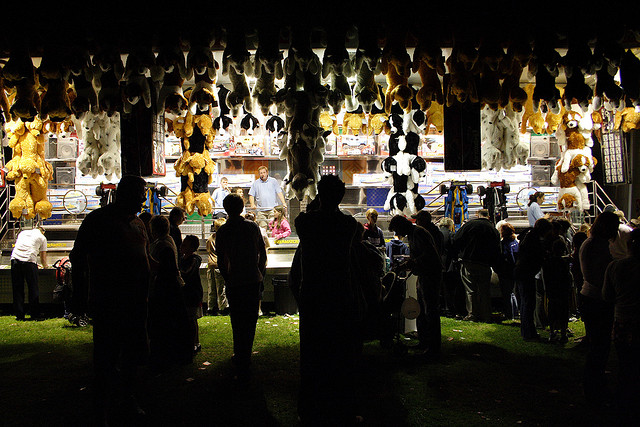<image>Will people win prizes easily here? I don't know if people will win prizes easily here. Will people win prizes easily here? I don't know if people will win prizes easily here. It may be difficult to win prizes. 